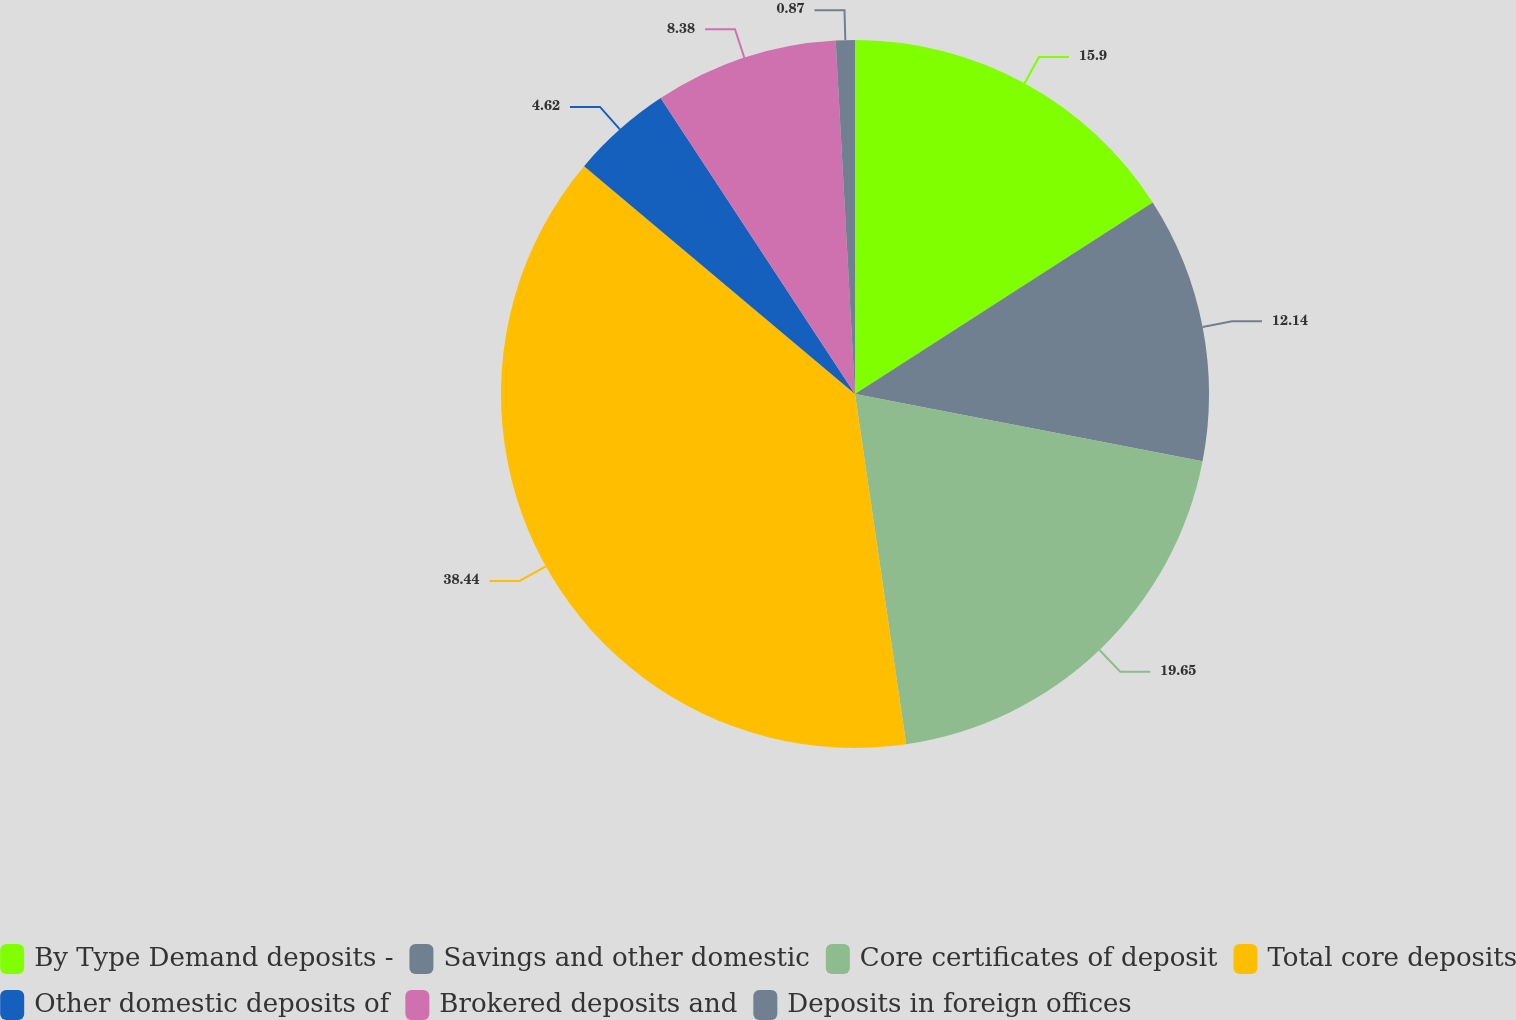Convert chart. <chart><loc_0><loc_0><loc_500><loc_500><pie_chart><fcel>By Type Demand deposits -<fcel>Savings and other domestic<fcel>Core certificates of deposit<fcel>Total core deposits<fcel>Other domestic deposits of<fcel>Brokered deposits and<fcel>Deposits in foreign offices<nl><fcel>15.9%<fcel>12.14%<fcel>19.65%<fcel>38.44%<fcel>4.62%<fcel>8.38%<fcel>0.87%<nl></chart> 